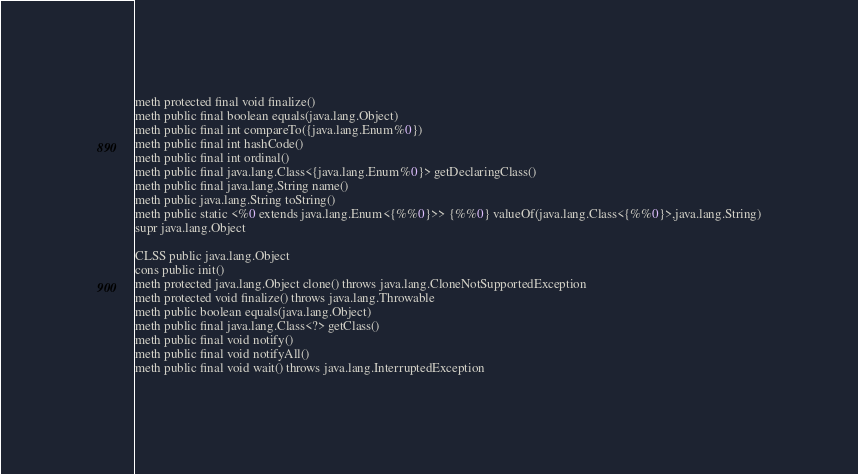Convert code to text. <code><loc_0><loc_0><loc_500><loc_500><_SML_>meth protected final void finalize()
meth public final boolean equals(java.lang.Object)
meth public final int compareTo({java.lang.Enum%0})
meth public final int hashCode()
meth public final int ordinal()
meth public final java.lang.Class<{java.lang.Enum%0}> getDeclaringClass()
meth public final java.lang.String name()
meth public java.lang.String toString()
meth public static <%0 extends java.lang.Enum<{%%0}>> {%%0} valueOf(java.lang.Class<{%%0}>,java.lang.String)
supr java.lang.Object

CLSS public java.lang.Object
cons public init()
meth protected java.lang.Object clone() throws java.lang.CloneNotSupportedException
meth protected void finalize() throws java.lang.Throwable
meth public boolean equals(java.lang.Object)
meth public final java.lang.Class<?> getClass()
meth public final void notify()
meth public final void notifyAll()
meth public final void wait() throws java.lang.InterruptedException</code> 